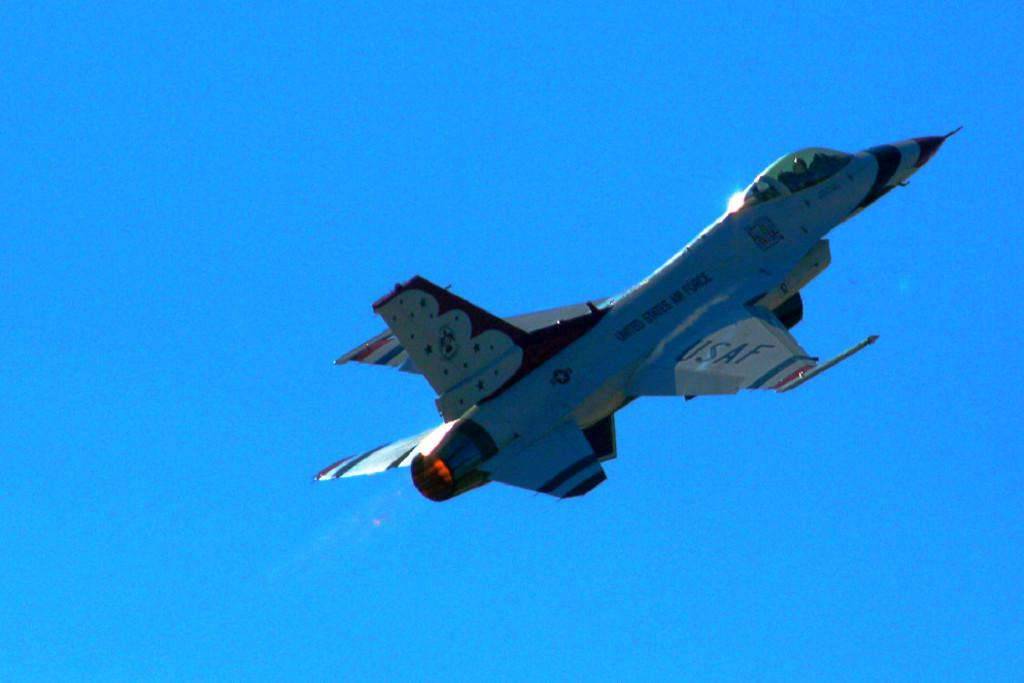Provide a one-sentence caption for the provided image. a United States Air Force or USAF military jet shooting in the sky. 